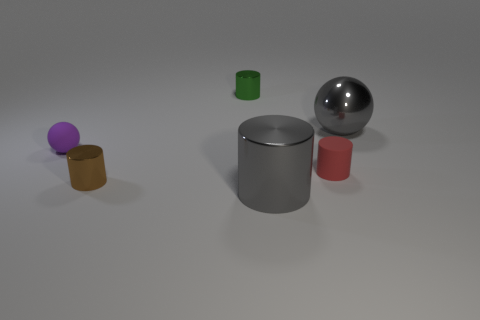The large thing behind the purple rubber object has what shape?
Your answer should be compact. Sphere. There is a shiny cylinder left of the small cylinder that is behind the ball to the right of the small matte cylinder; what size is it?
Provide a succinct answer. Small. Does the tiny green shiny object have the same shape as the red thing?
Your response must be concise. Yes. There is a cylinder that is both behind the small brown metal object and right of the green metallic cylinder; how big is it?
Provide a succinct answer. Small. There is another object that is the same shape as the purple matte object; what is its material?
Make the answer very short. Metal. What is the material of the ball that is to the left of the tiny cylinder that is behind the tiny red cylinder?
Your answer should be very brief. Rubber. There is a small green thing; does it have the same shape as the big metal object in front of the rubber cylinder?
Give a very brief answer. Yes. What number of matte things are small brown things or tiny cylinders?
Offer a terse response. 1. What is the color of the matte thing on the right side of the large shiny object that is on the left side of the gray thing to the right of the matte cylinder?
Offer a very short reply. Red. How many other things are there of the same material as the red cylinder?
Ensure brevity in your answer.  1. 